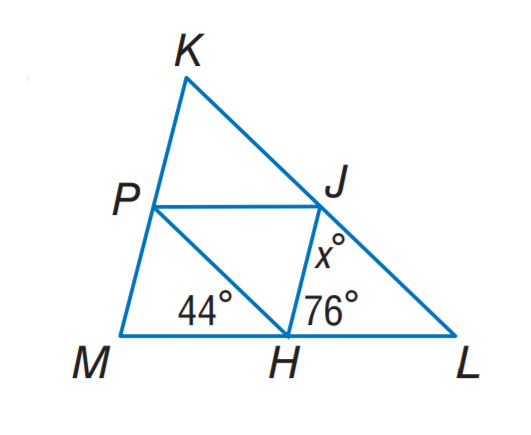Question: J H, J P, and P H are midsegments of \triangle K L M. Find x.
Choices:
A. 44
B. 56
C. 60
D. 76
Answer with the letter. Answer: C 